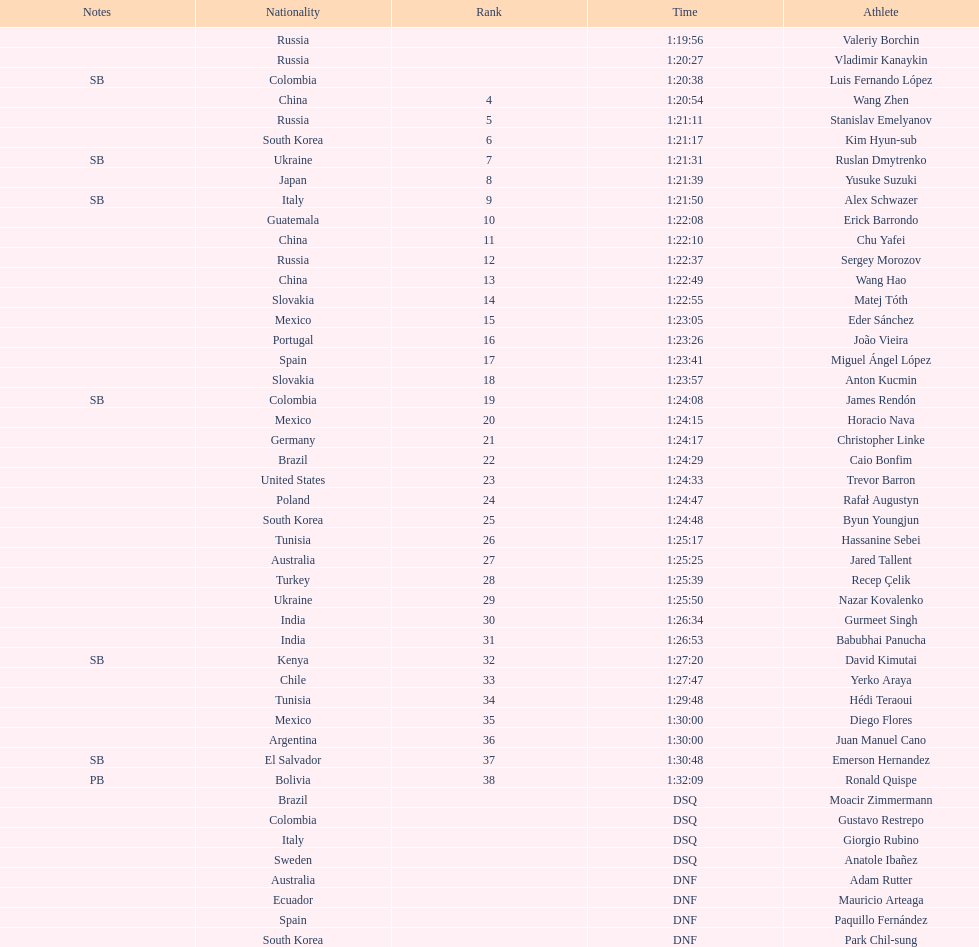Which athlete had the fastest time for the 20km? Valeriy Borchin. 